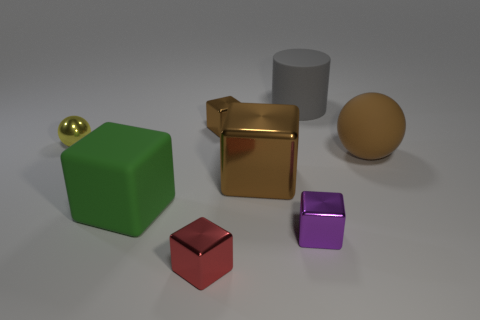What is the color of the rubber block? The rubber block appears to be green, showcasing a matte finish that is characteristic of rubber materials. 